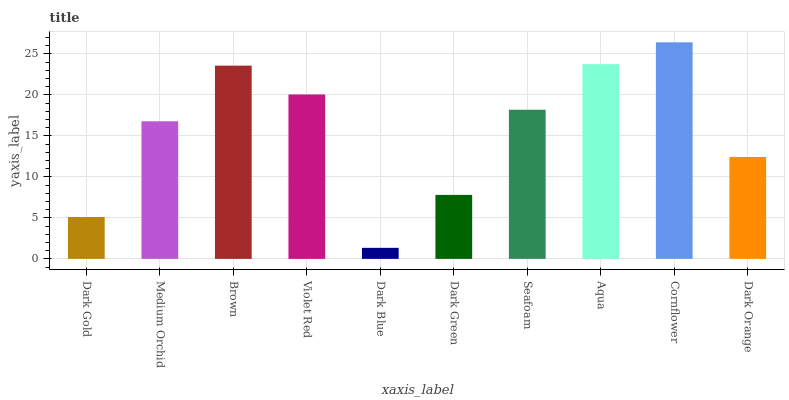Is Dark Blue the minimum?
Answer yes or no. Yes. Is Cornflower the maximum?
Answer yes or no. Yes. Is Medium Orchid the minimum?
Answer yes or no. No. Is Medium Orchid the maximum?
Answer yes or no. No. Is Medium Orchid greater than Dark Gold?
Answer yes or no. Yes. Is Dark Gold less than Medium Orchid?
Answer yes or no. Yes. Is Dark Gold greater than Medium Orchid?
Answer yes or no. No. Is Medium Orchid less than Dark Gold?
Answer yes or no. No. Is Seafoam the high median?
Answer yes or no. Yes. Is Medium Orchid the low median?
Answer yes or no. Yes. Is Violet Red the high median?
Answer yes or no. No. Is Dark Green the low median?
Answer yes or no. No. 